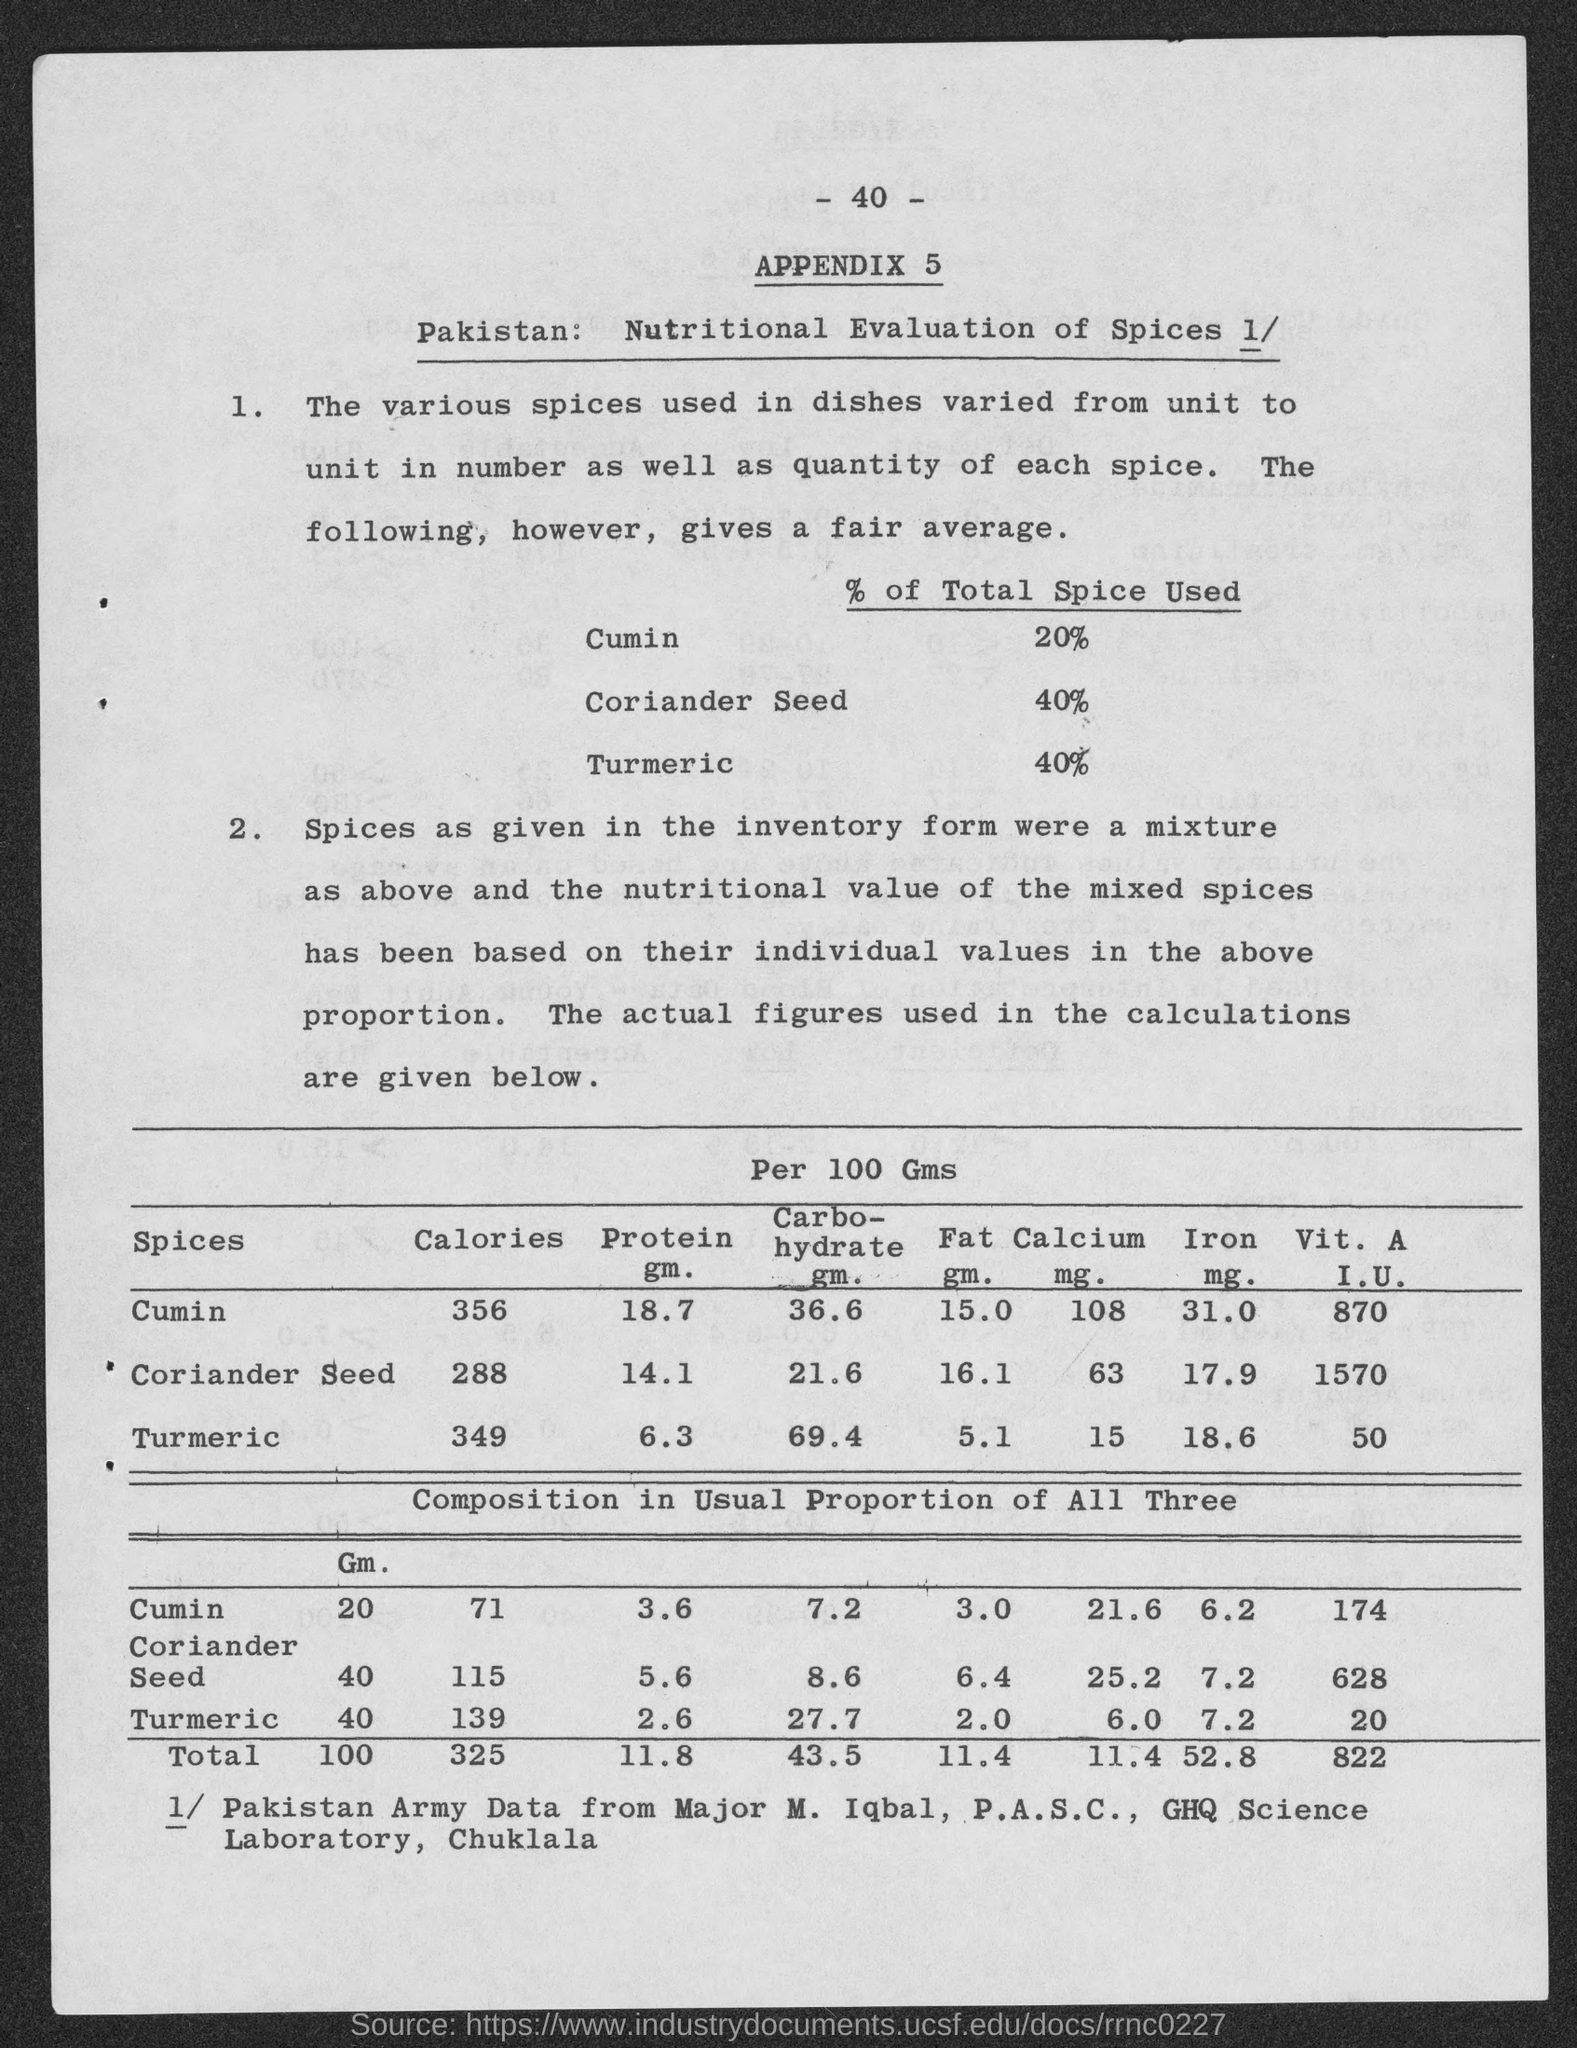what is the number at top of the page?
 40 